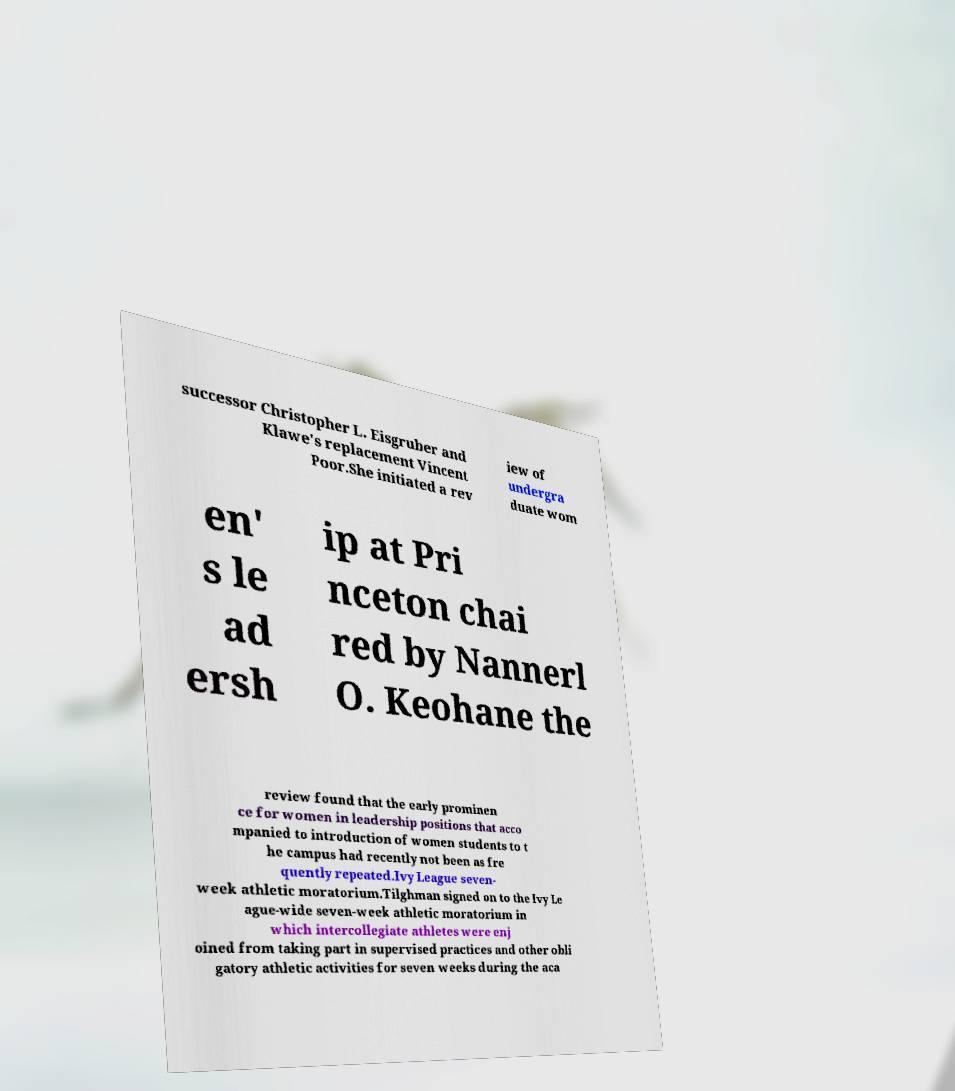Could you assist in decoding the text presented in this image and type it out clearly? successor Christopher L. Eisgruber and Klawe's replacement Vincent Poor.She initiated a rev iew of undergra duate wom en' s le ad ersh ip at Pri nceton chai red by Nannerl O. Keohane the review found that the early prominen ce for women in leadership positions that acco mpanied to introduction of women students to t he campus had recently not been as fre quently repeated.Ivy League seven- week athletic moratorium.Tilghman signed on to the Ivy Le ague-wide seven-week athletic moratorium in which intercollegiate athletes were enj oined from taking part in supervised practices and other obli gatory athletic activities for seven weeks during the aca 